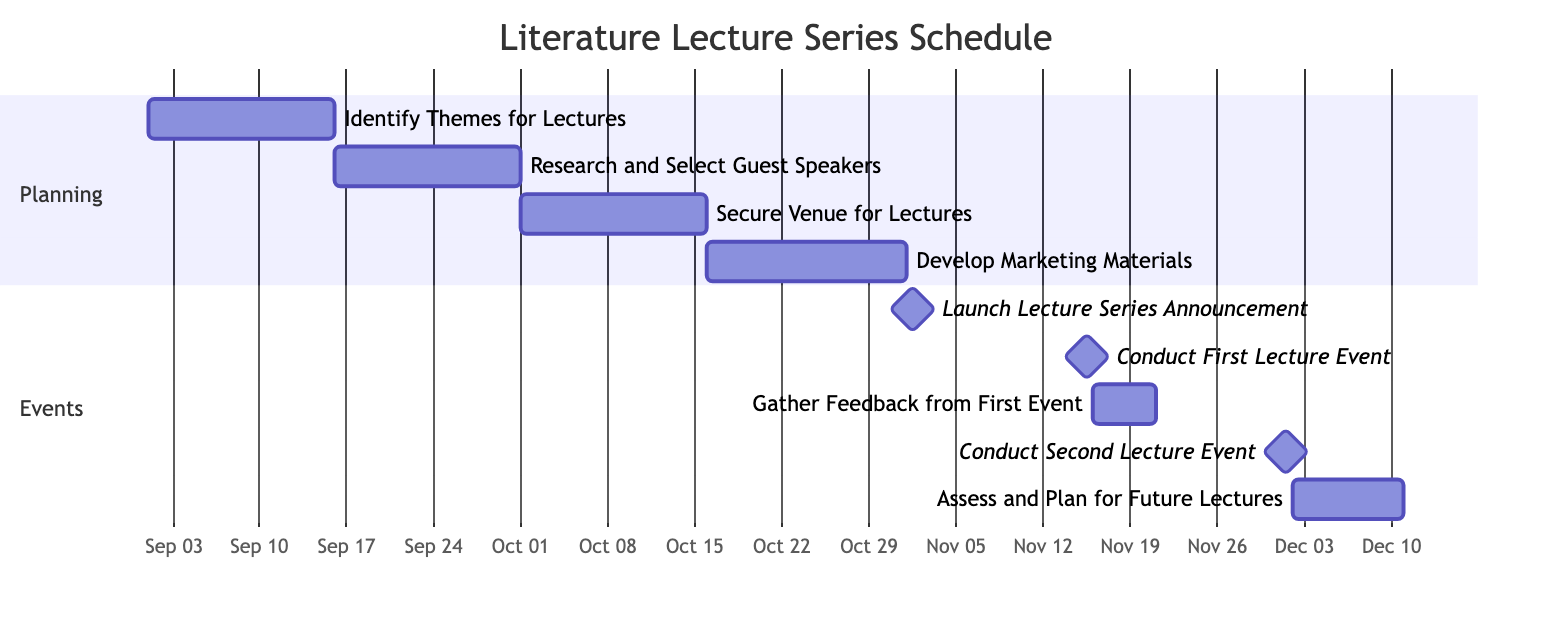What is the duration of the "Research and Select Guest Speakers" task? The "Research and Select Guest Speakers" task starts on September 16, 2023, and ends on September 30, 2023. To find the duration, we calculate the end date minus the start date, which gives us 15 days.
Answer: 15 days When does the "Secure Venue for Lectures" task start? The "Secure Venue for Lectures" task is listed after "Research and Select Guest Speakers," which starts on September 16 and ends on September 30. This task starts on October 1, 2023.
Answer: October 1, 2023 How many tasks are planned before the first lecture event? To answer, we count the tasks that occur before "Conduct First Lecture Event," which is on November 15, 2023. The tasks before it are "Identify Themes for Lectures," "Research and Select Guest Speakers," "Secure Venue for Lectures," and "Develop Marketing Materials," totaling four tasks.
Answer: 4 What task immediately follows the "Conduct First Lecture Event"? The task that follows "Conduct First Lecture Event," scheduled for November 15, 2023, is "Gather Feedback from First Event," which begins immediately after on November 16, 2023.
Answer: Gather Feedback from First Event What is the end date of the "Assess and Plan for Future Lectures" task? The "Assess and Plan for Future Lectures" task starts after the "Conduct Second Lecture Event" on December 1, 2023, and lasts for 9 days. Counting those days, it ends on December 10, 2023.
Answer: December 10, 2023 Which task is marked as a milestone on November 1, 2023? The milestone on November 1, 2023, is "Launch Lecture Series Announcement," which is a key event indicating that the lecture series is officially announced.
Answer: Launch Lecture Series Announcement What tasks share the same section in the Gantt chart? "Identify Themes for Lectures," "Research and Select Guest Speakers," "Secure Venue for Lectures," and "Develop Marketing Materials" share the "Planning" section in the Gantt chart.
Answer: Identify Themes for Lectures, Research and Select Guest Speakers, Secure Venue for Lectures, Develop Marketing Materials How long is the interval between the first and second lecture events? The first lecture event occurs on November 15, 2023, and the second on December 1, 2023. The interval between these two dates is 16 days, calculated by counting the days from November 15 to December 1.
Answer: 16 days 